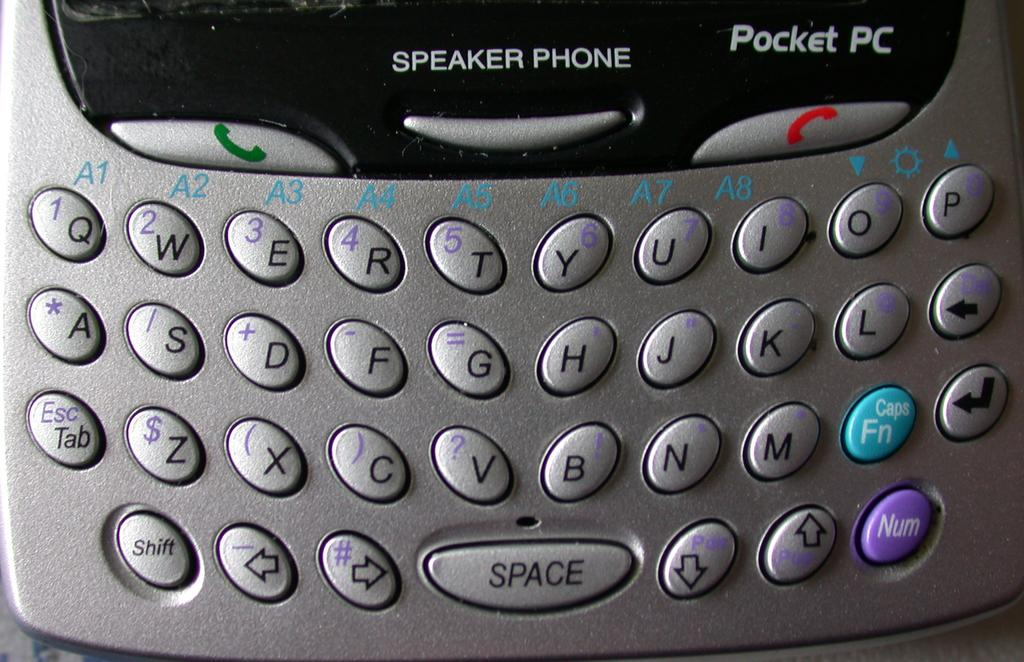<image>
Render a clear and concise summary of the photo. A Pocket PC device says speaker phone above the keyboard. 